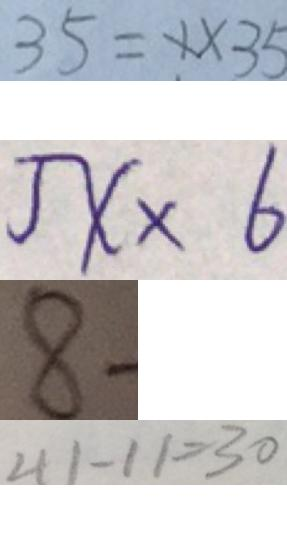<formula> <loc_0><loc_0><loc_500><loc_500>3 5 = 1 \times 3 5 
 5 x \times 6 
 8 - 
 4 1 - 1 1 = 3 0</formula> 